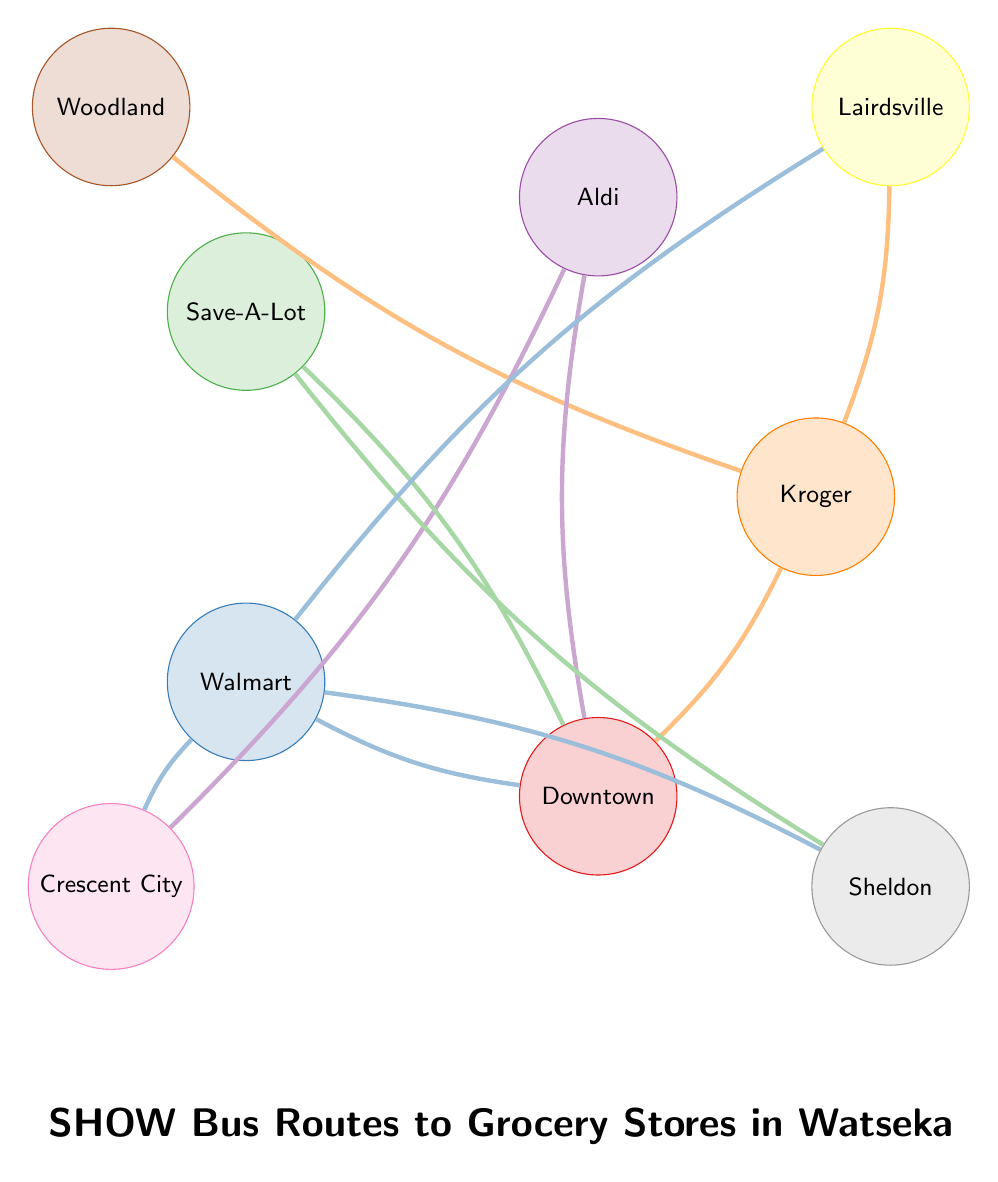How many grocery stores are connected to Downtown Watseka? By examining the diagram, we identify the lines connecting grocery stores to Downtown Watseka. The stores are Kroger, Aldi, Save-A-Lot, and Walmart Supercenter. Each of these stores has a connection to Downtown Watseka, resulting in a total of four connected grocery stores.
Answer: 4 Which grocery store is associated with the neighborhoods Woodland and Lairdsville? Looking at the connections, we see that Kroger has lines leading to both Woodland and Lairdsville. This indicates that Kroger is the grocery store connected to both neighborhoods.
Answer: Kroger What is the total number of neighborhoods represented in this diagram? Counting the neighborhood nodes present in the diagram, we identify the following neighborhoods: Downtown Watseka, Lairdsville, Woodland, Crescent City, and Sheldon. This gives us a total of five distinct neighborhoods.
Answer: 5 Which grocery store has connections to the most neighborhoods? We evaluate the connections for each grocery store: Kroger connects to three neighborhoods (Downtown Watseka, Lairdsville, Woodland), Aldi connects to two (Downtown Watseka, Crescent City), Save-A-Lot connects to two (Downtown Watseka, Sheldon), and Walmart Supercenter connects to four (Downtown Watseka, Lairdsville, Crescent City, Sheldon). Hence, Walmart Supercenter has the maximum connections.
Answer: Walmart Supercenter How many neighborhoods can be reached from Aldi? The diagram shows Aldi has connections to two neighborhoods: Downtown Watseka and Crescent City. Thus, the outreach of Aldi includes those two neighborhoods.
Answer: 2 Which neighborhood is accessible from the grocery store Save-A-Lot? Investigating the connections from Save-A-Lot, we find it is linked to Downtown Watseka and Sheldon. Therefore, these are the neighborhoods accessible from Save-A-Lot. The neighborhood in question is Downtown Watseka or Sheldon.
Answer: Downtown Watseka, Sheldon 